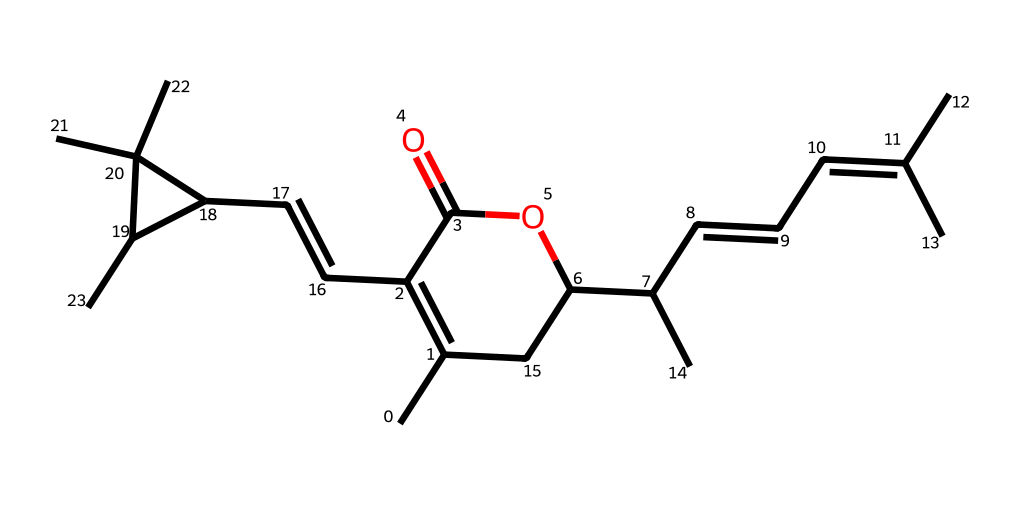What is the chemical name represented by this SMILES? The SMILES representation corresponds to the structure of pyrethrins, which are natural insecticides derived from chrysanthemum flowers.
Answer: pyrethrins How many carbon atoms are in the structure? By analyzing the SMILES, you can count the number of 'C' in the representation; there are 21 carbon atoms, detailing the complexity of the organic structure.
Answer: 21 What is the type of this chemical? The chemical is classified as a pesticide due to its use as a natural insecticide for pest control.
Answer: pesticide What functional group is present in this structure? The presence of the ‘C(=O)’ notation indicates the presence of an ester functional group in the molecule, which is characteristic of many insecticides.
Answer: ester How many rings are in this structure? The structure features two distinct cyclic components, identifiable by the 'C1' and 'C2' notations indicating ring formation in the structure.
Answer: 2 What is the primary source of this insecticide? Pyrethrins are naturally derived from the flowers of the chrysanthemum plant, which functions as the primary source of the chemical.
Answer: chrysanthemum 